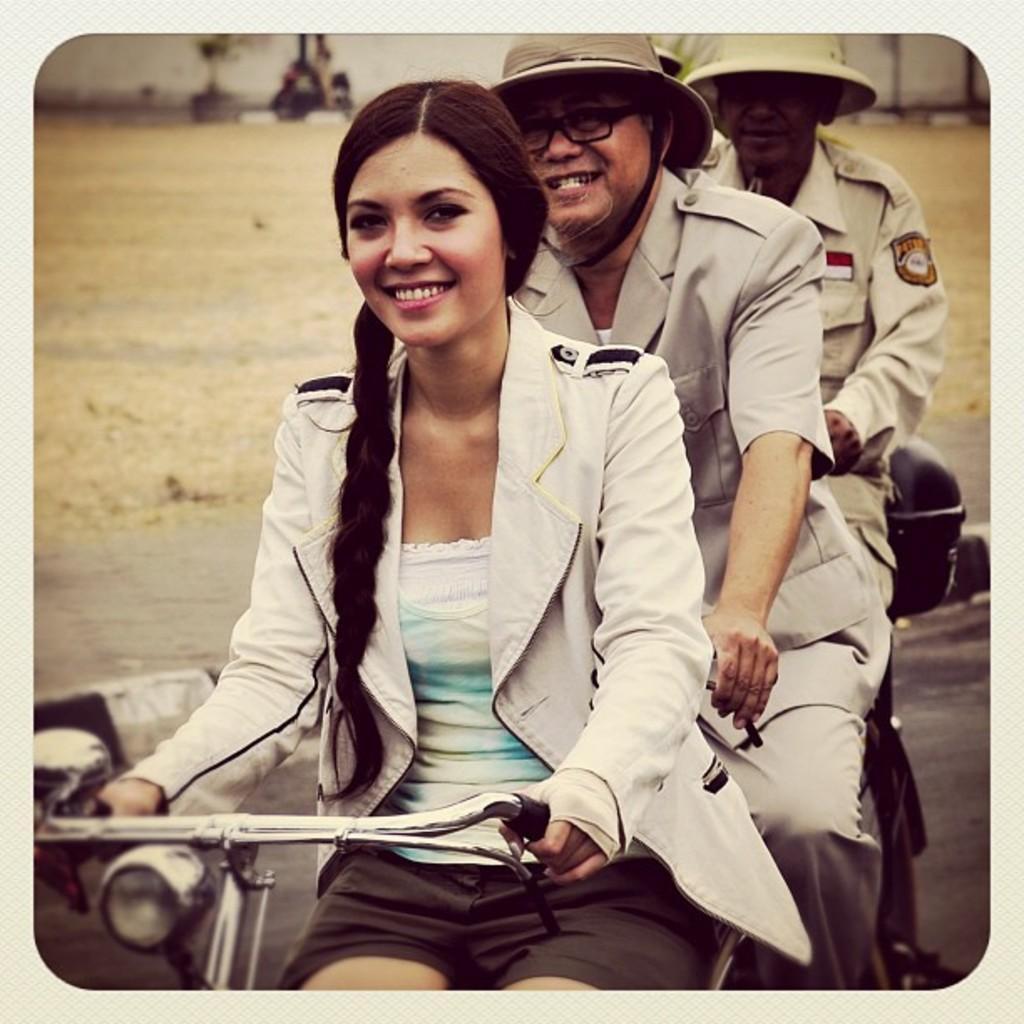In one or two sentences, can you explain what this image depicts? This image consists of a woman cycling on the road. And there are two men wearing hats are also riding bicycles. At the bottom, there is a road. In the background, there is green grass on the ground. 